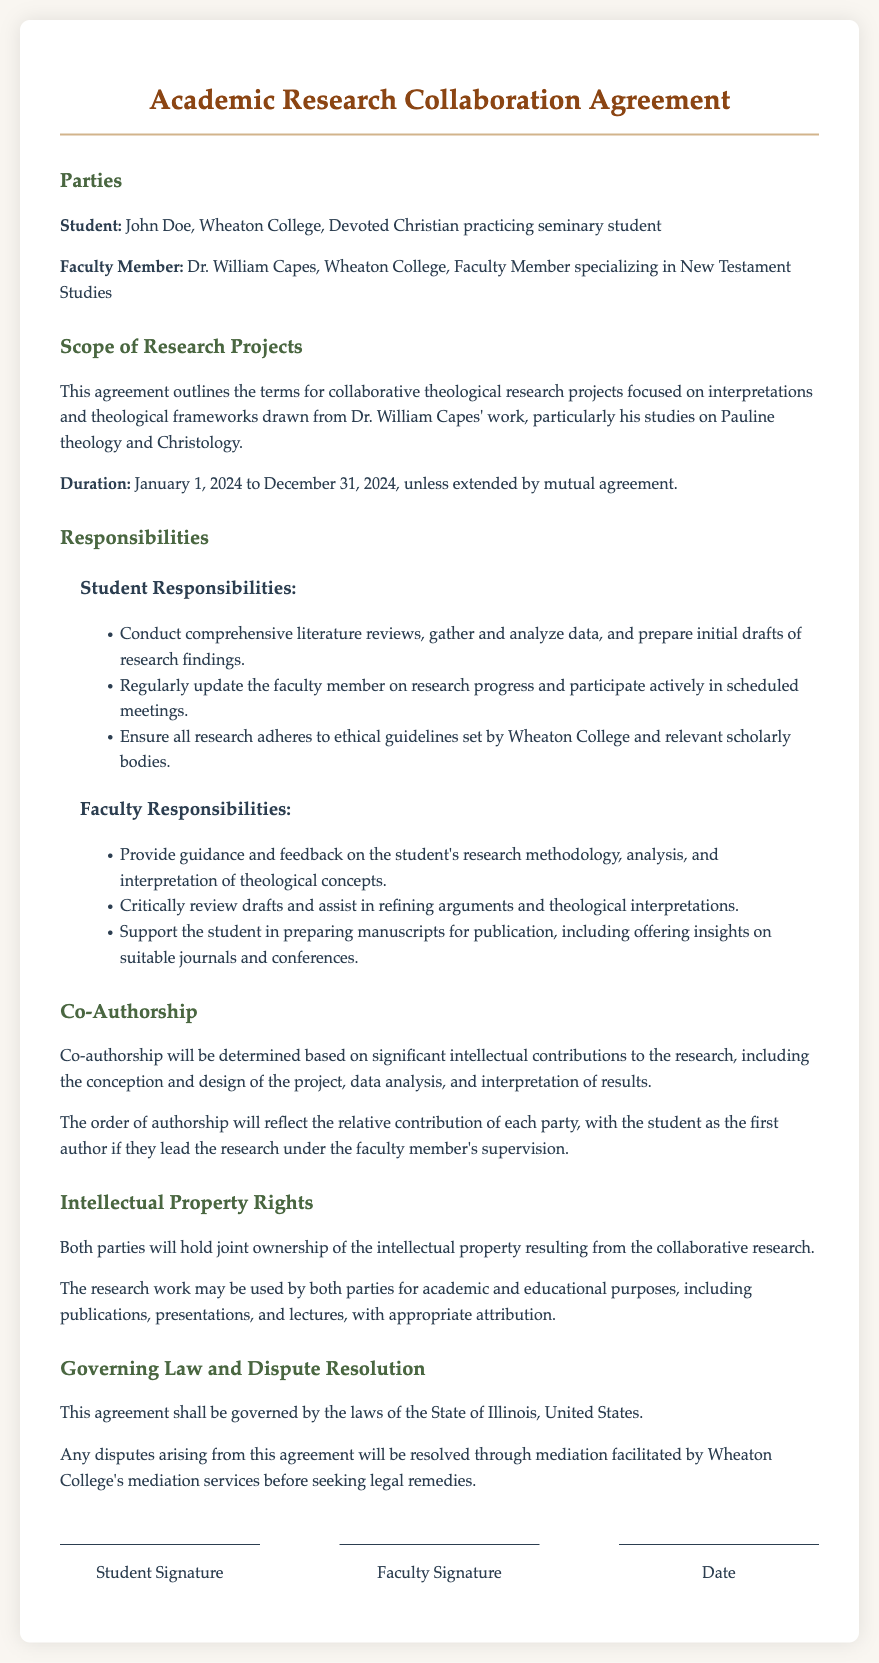What is the duration of the agreement? The duration of the agreement is specified in the document, from January 1, 2024, to December 31, 2024.
Answer: January 1, 2024 to December 31, 2024 Who is the faculty member associated with this agreement? The document identifies the faculty member as Dr. William Capes.
Answer: Dr. William Capes What are the student's primary responsibilities? The responsibilities listed for the student include conducting literature reviews and preparing initial drafts.
Answer: Conduct comprehensive literature reviews, gather and analyze data, and prepare initial drafts of research findings What will determine co-authorship? Co-authorship is determined by significant intellectual contributions to the research project.
Answer: Significant intellectual contributions Which law governs this agreement? The governing law for this agreement is mentioned in the document as the law of the State of Illinois.
Answer: State of Illinois What type of resolution is mentioned for disputes? The document states that disputes will be resolved through mediation.
Answer: Mediation What is the primary focus of the collaborative research projects? The focus of the research projects is outlined in the document, emphasizing Dr. Capes' theological work.
Answer: Interpretations and theological frameworks drawn from Dr. William Capes' work What will both parties hold regarding intellectual property? The document describes the ownership of intellectual property resulting from their collaboration.
Answer: Joint ownership 